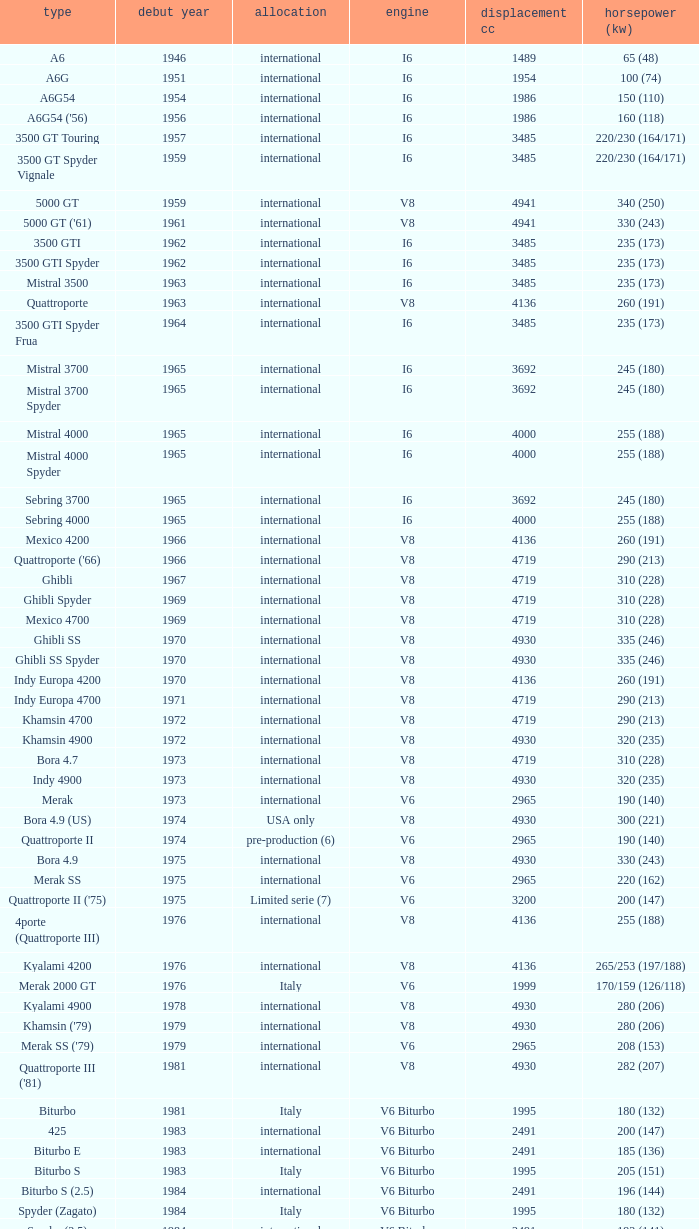What is the total number of First Year, when Displacement CC is greater than 4719, when Engine is V8, when Power HP (kW) is "335 (246)", and when Model is "Ghibli SS"? 1.0. 